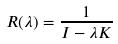<formula> <loc_0><loc_0><loc_500><loc_500>R ( \lambda ) = \frac { 1 } { I - \lambda K }</formula> 